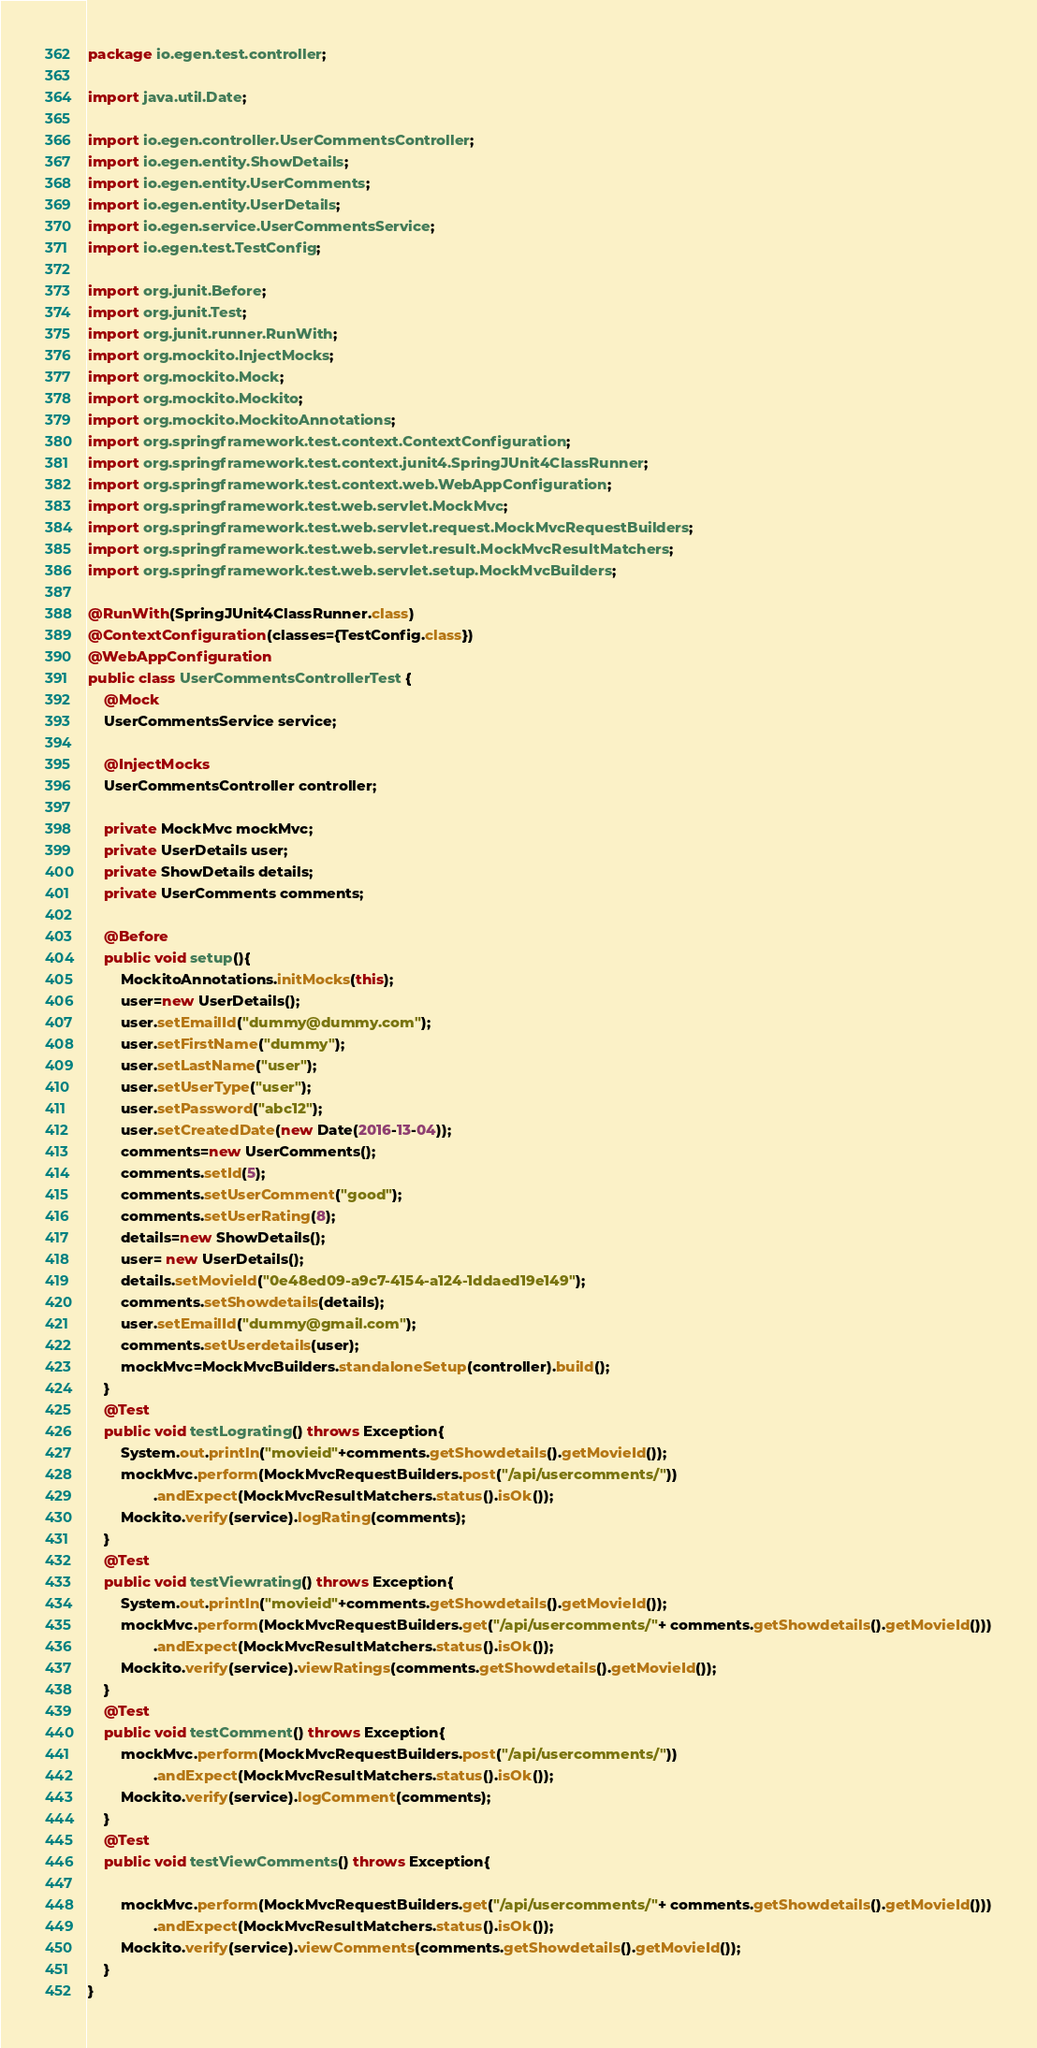<code> <loc_0><loc_0><loc_500><loc_500><_Java_>package io.egen.test.controller;

import java.util.Date;

import io.egen.controller.UserCommentsController;
import io.egen.entity.ShowDetails;
import io.egen.entity.UserComments;
import io.egen.entity.UserDetails;
import io.egen.service.UserCommentsService;
import io.egen.test.TestConfig;

import org.junit.Before;
import org.junit.Test;
import org.junit.runner.RunWith;
import org.mockito.InjectMocks;
import org.mockito.Mock;
import org.mockito.Mockito;
import org.mockito.MockitoAnnotations;
import org.springframework.test.context.ContextConfiguration;
import org.springframework.test.context.junit4.SpringJUnit4ClassRunner;
import org.springframework.test.context.web.WebAppConfiguration;
import org.springframework.test.web.servlet.MockMvc;
import org.springframework.test.web.servlet.request.MockMvcRequestBuilders;
import org.springframework.test.web.servlet.result.MockMvcResultMatchers;
import org.springframework.test.web.servlet.setup.MockMvcBuilders;

@RunWith(SpringJUnit4ClassRunner.class)
@ContextConfiguration(classes={TestConfig.class})
@WebAppConfiguration
public class UserCommentsControllerTest {
	@Mock
	UserCommentsService service;
	
	@InjectMocks
    UserCommentsController controller;
	
	private MockMvc mockMvc;
	private UserDetails user;
	private ShowDetails details;
	private UserComments comments;
	
	@Before
	public void setup(){
		MockitoAnnotations.initMocks(this);
		user=new UserDetails();
		user.setEmailId("dummy@dummy.com");
		user.setFirstName("dummy");
		user.setLastName("user");
		user.setUserType("user");
		user.setPassword("abc12");
		user.setCreatedDate(new Date(2016-13-04));
		comments=new UserComments();
		comments.setId(5);
		comments.setUserComment("good");
		comments.setUserRating(8);
		details=new ShowDetails();
		user= new UserDetails();
		details.setMovieId("0e48ed09-a9c7-4154-a124-1ddaed19e149");
		comments.setShowdetails(details);
	    user.setEmailId("dummy@gmail.com");
		comments.setUserdetails(user);	
		mockMvc=MockMvcBuilders.standaloneSetup(controller).build();
	}
	@Test
	public void testLograting() throws Exception{
		System.out.println("movieid"+comments.getShowdetails().getMovieId());
		mockMvc.perform(MockMvcRequestBuilders.post("/api/usercomments/"))
				.andExpect(MockMvcResultMatchers.status().isOk());
		Mockito.verify(service).logRating(comments);
	}
	@Test
	public void testViewrating() throws Exception{
		System.out.println("movieid"+comments.getShowdetails().getMovieId());
		mockMvc.perform(MockMvcRequestBuilders.get("/api/usercomments/"+ comments.getShowdetails().getMovieId()))
				.andExpect(MockMvcResultMatchers.status().isOk());
		Mockito.verify(service).viewRatings(comments.getShowdetails().getMovieId());
	}
	@Test
	public void testComment() throws Exception{
		mockMvc.perform(MockMvcRequestBuilders.post("/api/usercomments/"))
				.andExpect(MockMvcResultMatchers.status().isOk());
		Mockito.verify(service).logComment(comments);
	}
	@Test
	public void testViewComments() throws Exception{
		
		mockMvc.perform(MockMvcRequestBuilders.get("/api/usercomments/"+ comments.getShowdetails().getMovieId()))
				.andExpect(MockMvcResultMatchers.status().isOk());
		Mockito.verify(service).viewComments(comments.getShowdetails().getMovieId());
	}
}
</code> 